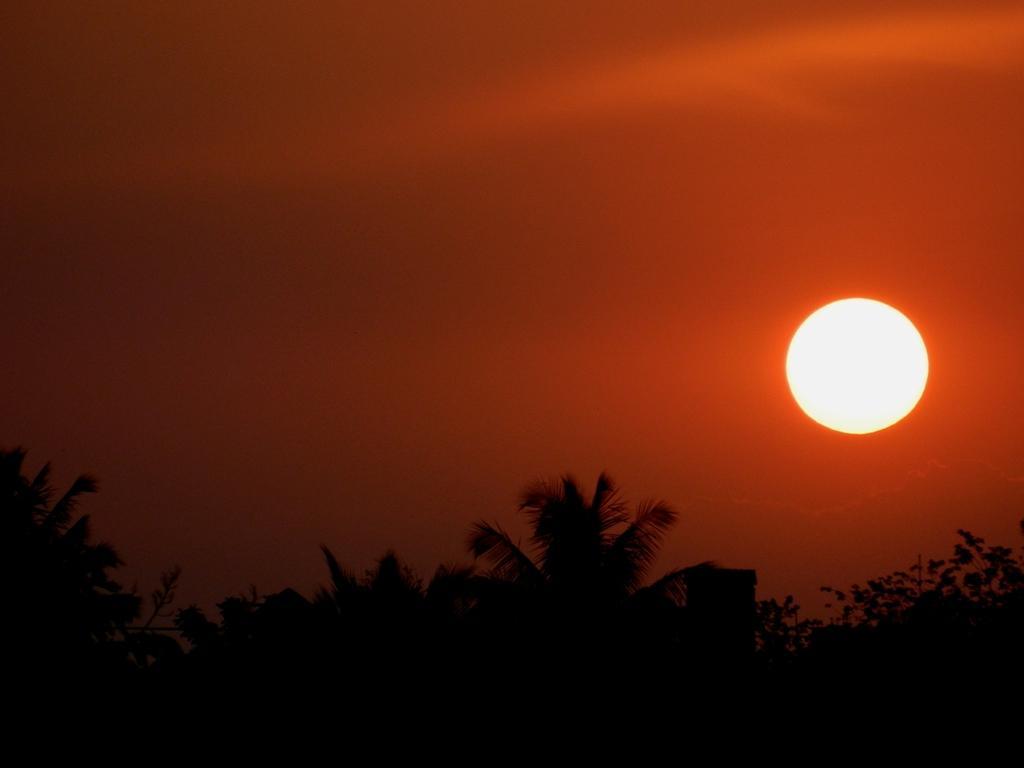How would you summarize this image in a sentence or two? In this picture I can see trees and the sun in the sky 